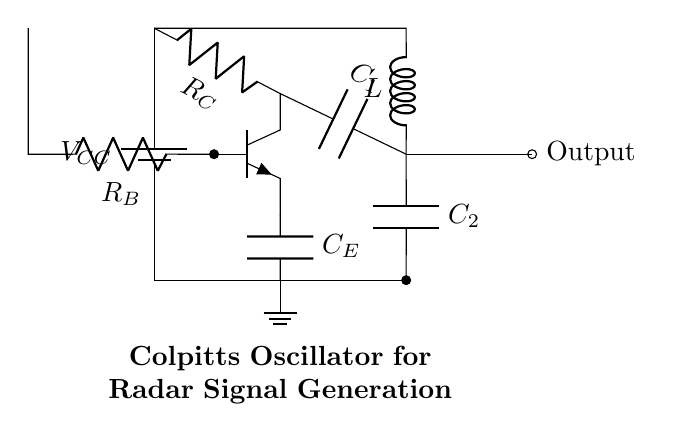What type of transistor is used in this circuit? The circuit diagram shows an NPN transistor, indicated by the symbol with three terminals labeled Collector, Base, and Emitter.
Answer: NPN What is the function of the capacitors in the Colpitts oscillator? In a Colpitts oscillator, the capacitors (C1 and C2) form a voltage divider that helps determine the oscillator's frequency of oscillation by influencing the feedback in the circuit.
Answer: Frequency determination How many resistors are present in this circuit? The circuit includes two resistors: Rc and Rb. Their roles include setting biasing and controlling the transistor's operation.
Answer: Two What component connects the output to the circuit? The output is connected via a node labeled 'Output,' which leads away from the junction connected to C2. This indicates that the output signal can be taken from the oscillation generated within the circuit.
Answer: Output node What is the role of the inductor in this oscillator circuit? The inductor, labeled 'L,' in conjunction with the capacitors forms a resonant circuit that helps establish the oscillation frequency, contributing to the generation of radar signals in the application context.
Answer: Resonance formation What is the power supply voltage indicated in the circuit? The power supply is connected at the top labeled as Vcc, which supplies the necessary voltage for the operation of the circuit. The specific voltage isn't provided in the diagram since it varies based on application, but it's essential for providing the power needed for the active components.
Answer: Vcc 